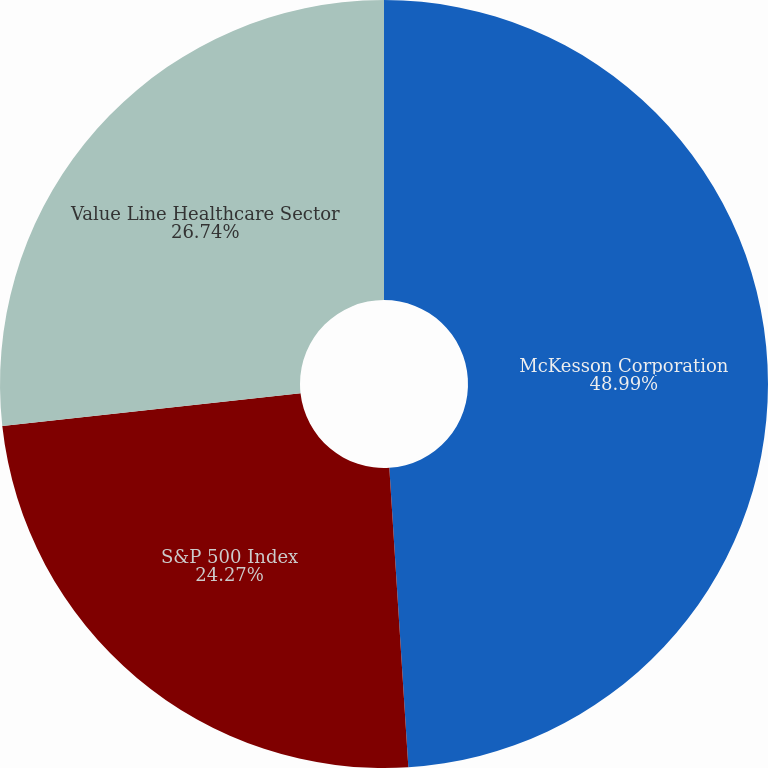<chart> <loc_0><loc_0><loc_500><loc_500><pie_chart><fcel>McKesson Corporation<fcel>S&P 500 Index<fcel>Value Line Healthcare Sector<nl><fcel>48.99%<fcel>24.27%<fcel>26.74%<nl></chart> 